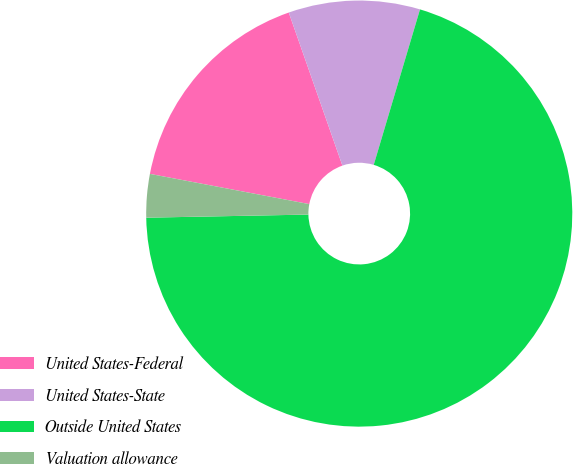<chart> <loc_0><loc_0><loc_500><loc_500><pie_chart><fcel>United States-Federal<fcel>United States-State<fcel>Outside United States<fcel>Valuation allowance<nl><fcel>16.65%<fcel>9.97%<fcel>70.09%<fcel>3.29%<nl></chart> 